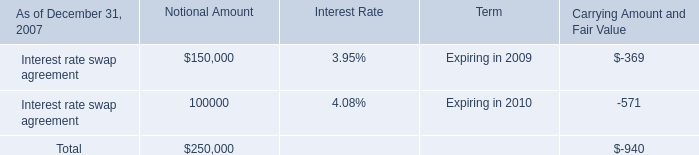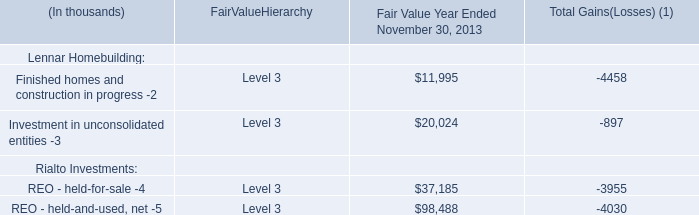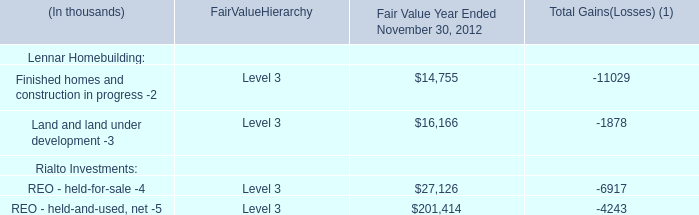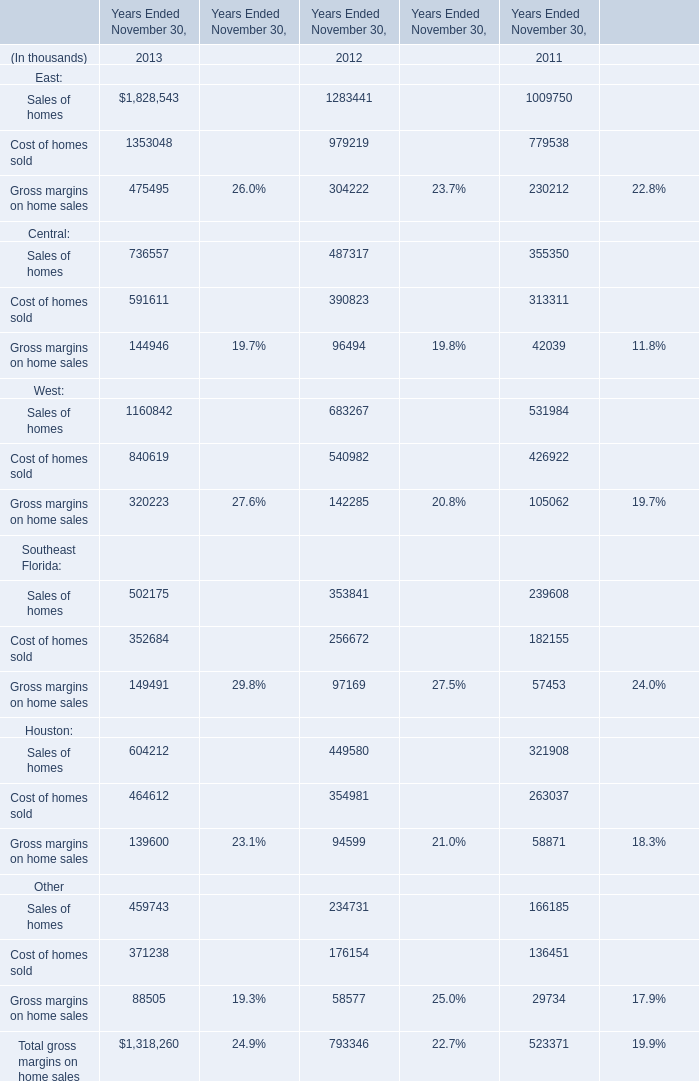what is the net change in the balance of other long-term notes receivable during 2007? 
Computations: (11.0 - 4.3)
Answer: 6.7. 